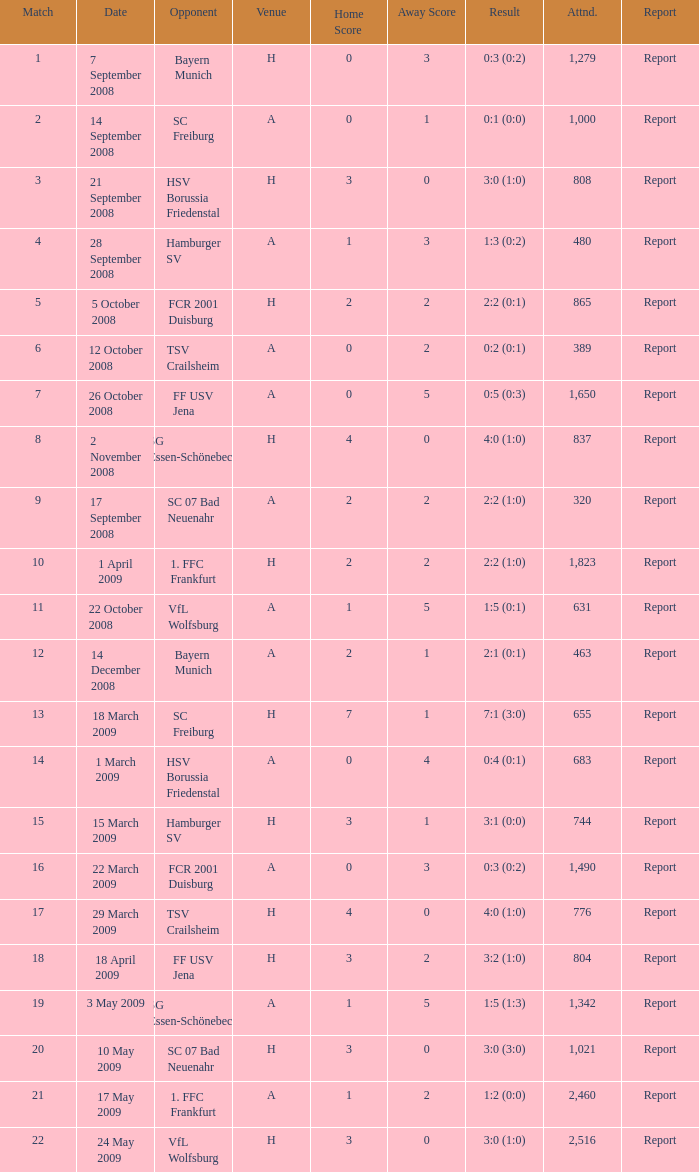Which match did FCR 2001 Duisburg participate as the opponent? 21.0. 